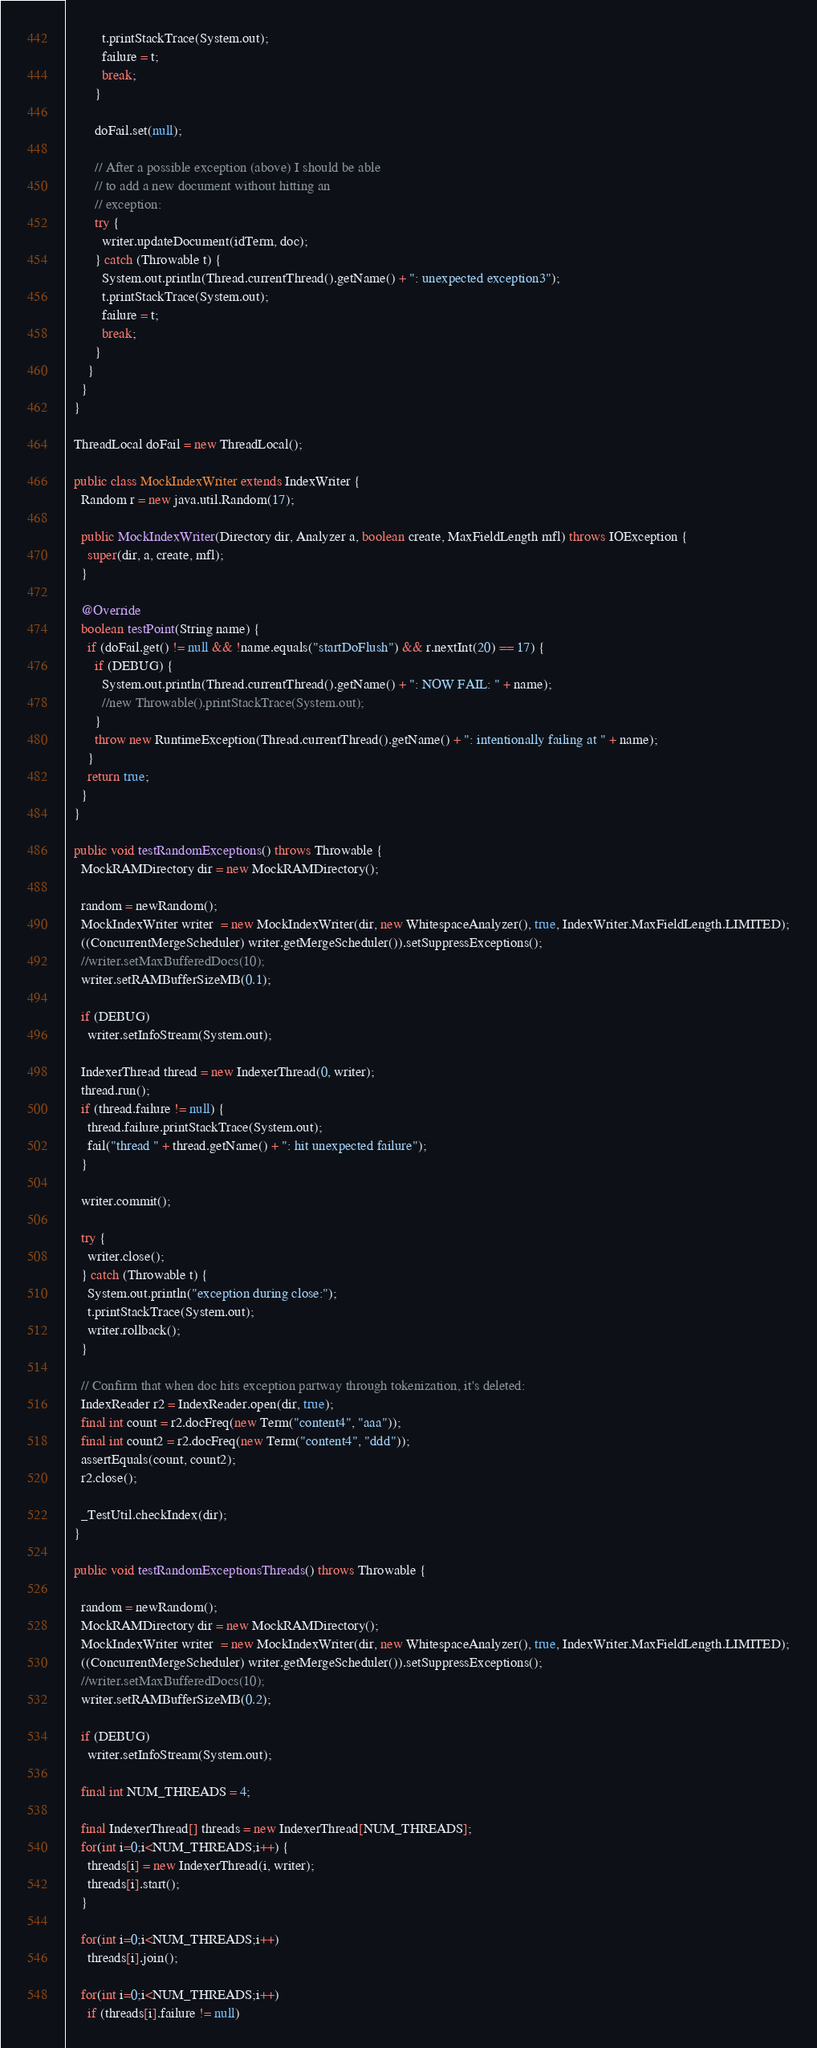<code> <loc_0><loc_0><loc_500><loc_500><_Java_>          t.printStackTrace(System.out);
          failure = t;
          break;
        }

        doFail.set(null);

        // After a possible exception (above) I should be able
        // to add a new document without hitting an
        // exception:
        try {
          writer.updateDocument(idTerm, doc);
        } catch (Throwable t) {
          System.out.println(Thread.currentThread().getName() + ": unexpected exception3");
          t.printStackTrace(System.out);
          failure = t;
          break;
        }
      }
    }
  }

  ThreadLocal doFail = new ThreadLocal();

  public class MockIndexWriter extends IndexWriter {
    Random r = new java.util.Random(17);

    public MockIndexWriter(Directory dir, Analyzer a, boolean create, MaxFieldLength mfl) throws IOException {
      super(dir, a, create, mfl);
    }

    @Override
    boolean testPoint(String name) {
      if (doFail.get() != null && !name.equals("startDoFlush") && r.nextInt(20) == 17) {
        if (DEBUG) {
          System.out.println(Thread.currentThread().getName() + ": NOW FAIL: " + name);
          //new Throwable().printStackTrace(System.out);
        }
        throw new RuntimeException(Thread.currentThread().getName() + ": intentionally failing at " + name);
      }
      return true;
    }
  }

  public void testRandomExceptions() throws Throwable {
    MockRAMDirectory dir = new MockRAMDirectory();

    random = newRandom();
    MockIndexWriter writer  = new MockIndexWriter(dir, new WhitespaceAnalyzer(), true, IndexWriter.MaxFieldLength.LIMITED);
    ((ConcurrentMergeScheduler) writer.getMergeScheduler()).setSuppressExceptions();
    //writer.setMaxBufferedDocs(10);
    writer.setRAMBufferSizeMB(0.1);

    if (DEBUG)
      writer.setInfoStream(System.out);

    IndexerThread thread = new IndexerThread(0, writer);
    thread.run();
    if (thread.failure != null) {
      thread.failure.printStackTrace(System.out);
      fail("thread " + thread.getName() + ": hit unexpected failure");
    }

    writer.commit();

    try {
      writer.close();
    } catch (Throwable t) {
      System.out.println("exception during close:");
      t.printStackTrace(System.out);
      writer.rollback();
    }

    // Confirm that when doc hits exception partway through tokenization, it's deleted:
    IndexReader r2 = IndexReader.open(dir, true);
    final int count = r2.docFreq(new Term("content4", "aaa"));
    final int count2 = r2.docFreq(new Term("content4", "ddd"));
    assertEquals(count, count2);
    r2.close();

    _TestUtil.checkIndex(dir);
  }

  public void testRandomExceptionsThreads() throws Throwable {

    random = newRandom();
    MockRAMDirectory dir = new MockRAMDirectory();
    MockIndexWriter writer  = new MockIndexWriter(dir, new WhitespaceAnalyzer(), true, IndexWriter.MaxFieldLength.LIMITED);
    ((ConcurrentMergeScheduler) writer.getMergeScheduler()).setSuppressExceptions();
    //writer.setMaxBufferedDocs(10);
    writer.setRAMBufferSizeMB(0.2);

    if (DEBUG)
      writer.setInfoStream(System.out);

    final int NUM_THREADS = 4;

    final IndexerThread[] threads = new IndexerThread[NUM_THREADS];
    for(int i=0;i<NUM_THREADS;i++) {
      threads[i] = new IndexerThread(i, writer);
      threads[i].start();
    }

    for(int i=0;i<NUM_THREADS;i++)
      threads[i].join();

    for(int i=0;i<NUM_THREADS;i++)
      if (threads[i].failure != null)</code> 